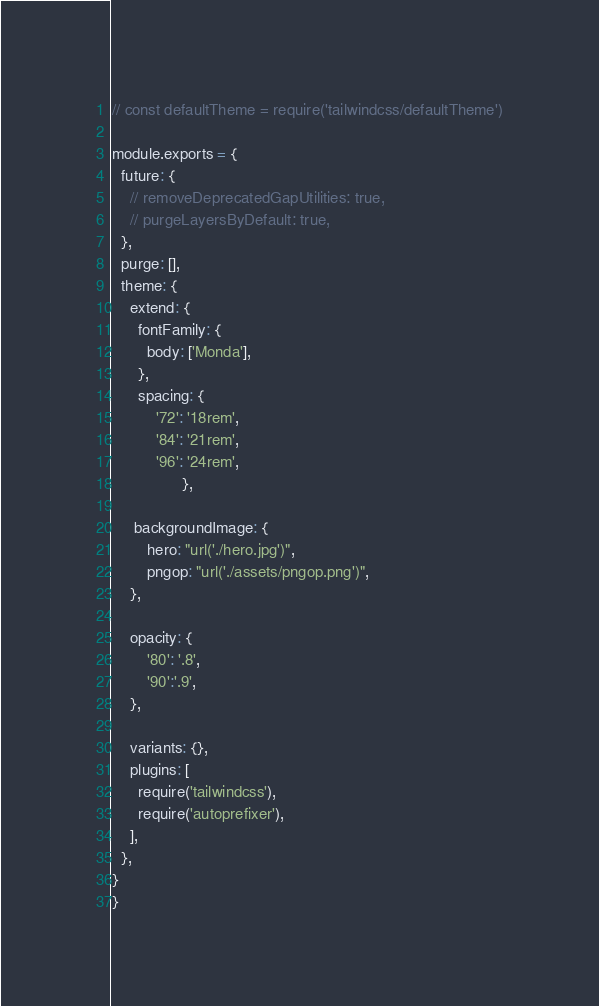Convert code to text. <code><loc_0><loc_0><loc_500><loc_500><_JavaScript_>// const defaultTheme = require('tailwindcss/defaultTheme')

module.exports = {
  future: {
    // removeDeprecatedGapUtilities: true,
    // purgeLayersByDefault: true,
  },
  purge: [],
  theme: {
    extend: {
      fontFamily: {
        body: ['Monda'],
      },
      spacing: {
          '72': '18rem',
          '84': '21rem',
          '96': '24rem',
                },
        
     backgroundImage: {
        hero: "url('./hero.jpg')",
        pngop: "url('./assets/pngop.png')",
    },

    opacity: {
        '80': '.8',
        '90':'.9',
    },

    variants: {},
    plugins: [
      require('tailwindcss'),
      require('autoprefixer'),
    ],
  },
}
}
</code> 